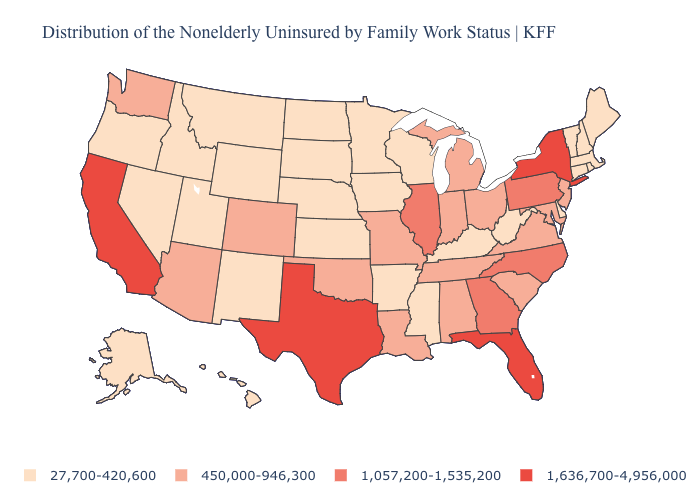Among the states that border Iowa , which have the lowest value?
Give a very brief answer. Minnesota, Nebraska, South Dakota, Wisconsin. Name the states that have a value in the range 27,700-420,600?
Answer briefly. Alaska, Arkansas, Connecticut, Delaware, Hawaii, Idaho, Iowa, Kansas, Kentucky, Maine, Massachusetts, Minnesota, Mississippi, Montana, Nebraska, Nevada, New Hampshire, New Mexico, North Dakota, Oregon, Rhode Island, South Dakota, Utah, Vermont, West Virginia, Wisconsin, Wyoming. Does New Hampshire have a higher value than Colorado?
Answer briefly. No. What is the value of South Dakota?
Concise answer only. 27,700-420,600. Which states hav the highest value in the Northeast?
Answer briefly. New York. What is the value of New Mexico?
Be succinct. 27,700-420,600. What is the value of Vermont?
Write a very short answer. 27,700-420,600. Name the states that have a value in the range 1,636,700-4,956,000?
Concise answer only. California, Florida, New York, Texas. Does Maine have a higher value than Arizona?
Keep it brief. No. Does Georgia have the highest value in the South?
Answer briefly. No. What is the value of California?
Be succinct. 1,636,700-4,956,000. Does New Hampshire have the lowest value in the USA?
Quick response, please. Yes. Name the states that have a value in the range 450,000-946,300?
Be succinct. Alabama, Arizona, Colorado, Indiana, Louisiana, Maryland, Michigan, Missouri, New Jersey, Ohio, Oklahoma, South Carolina, Tennessee, Virginia, Washington. How many symbols are there in the legend?
Short answer required. 4. What is the highest value in the Northeast ?
Be succinct. 1,636,700-4,956,000. 